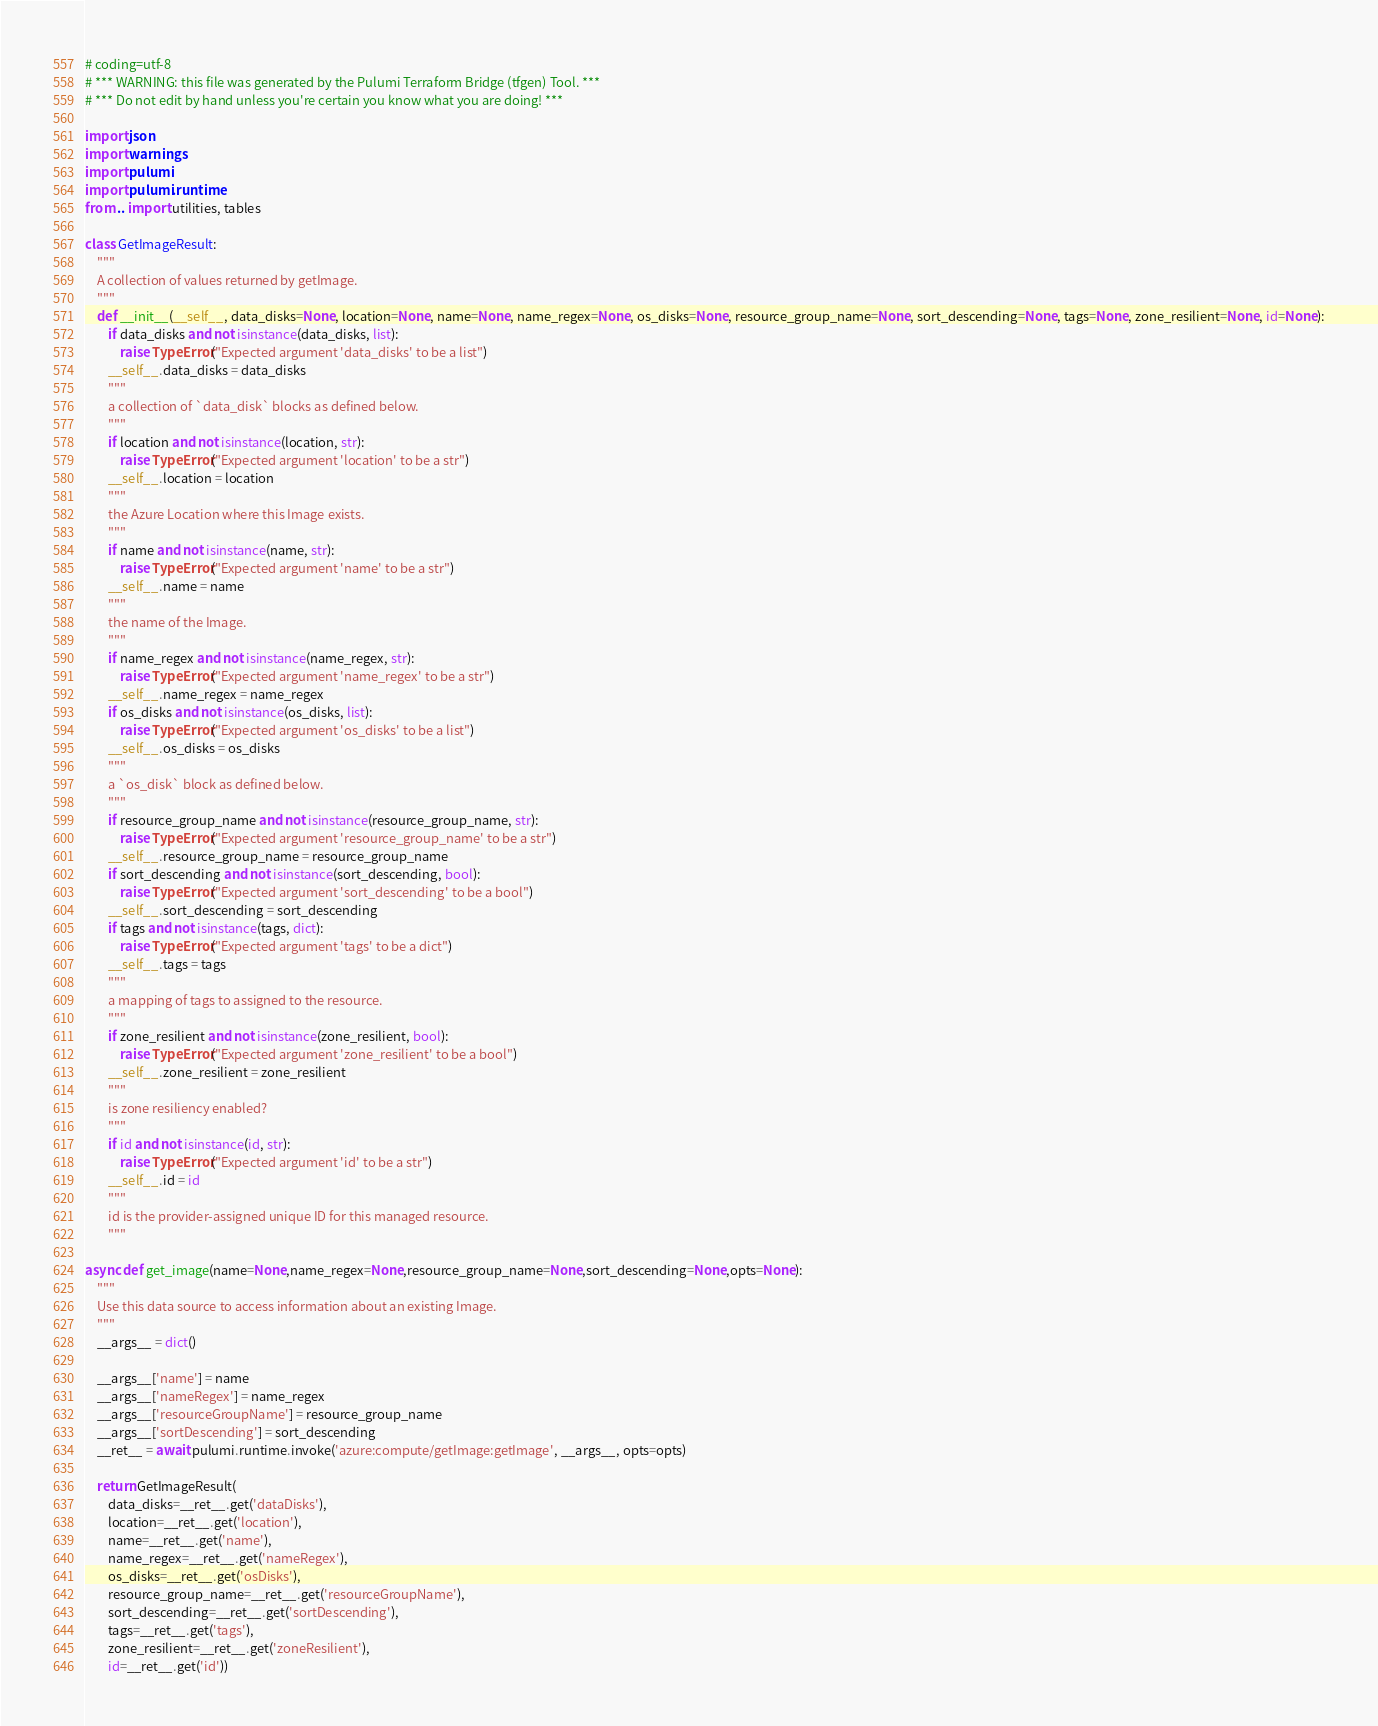<code> <loc_0><loc_0><loc_500><loc_500><_Python_># coding=utf-8
# *** WARNING: this file was generated by the Pulumi Terraform Bridge (tfgen) Tool. ***
# *** Do not edit by hand unless you're certain you know what you are doing! ***

import json
import warnings
import pulumi
import pulumi.runtime
from .. import utilities, tables

class GetImageResult:
    """
    A collection of values returned by getImage.
    """
    def __init__(__self__, data_disks=None, location=None, name=None, name_regex=None, os_disks=None, resource_group_name=None, sort_descending=None, tags=None, zone_resilient=None, id=None):
        if data_disks and not isinstance(data_disks, list):
            raise TypeError("Expected argument 'data_disks' to be a list")
        __self__.data_disks = data_disks
        """
        a collection of `data_disk` blocks as defined below.
        """
        if location and not isinstance(location, str):
            raise TypeError("Expected argument 'location' to be a str")
        __self__.location = location
        """
        the Azure Location where this Image exists.
        """
        if name and not isinstance(name, str):
            raise TypeError("Expected argument 'name' to be a str")
        __self__.name = name
        """
        the name of the Image.
        """
        if name_regex and not isinstance(name_regex, str):
            raise TypeError("Expected argument 'name_regex' to be a str")
        __self__.name_regex = name_regex
        if os_disks and not isinstance(os_disks, list):
            raise TypeError("Expected argument 'os_disks' to be a list")
        __self__.os_disks = os_disks
        """
        a `os_disk` block as defined below.
        """
        if resource_group_name and not isinstance(resource_group_name, str):
            raise TypeError("Expected argument 'resource_group_name' to be a str")
        __self__.resource_group_name = resource_group_name
        if sort_descending and not isinstance(sort_descending, bool):
            raise TypeError("Expected argument 'sort_descending' to be a bool")
        __self__.sort_descending = sort_descending
        if tags and not isinstance(tags, dict):
            raise TypeError("Expected argument 'tags' to be a dict")
        __self__.tags = tags
        """
        a mapping of tags to assigned to the resource.
        """
        if zone_resilient and not isinstance(zone_resilient, bool):
            raise TypeError("Expected argument 'zone_resilient' to be a bool")
        __self__.zone_resilient = zone_resilient
        """
        is zone resiliency enabled?
        """
        if id and not isinstance(id, str):
            raise TypeError("Expected argument 'id' to be a str")
        __self__.id = id
        """
        id is the provider-assigned unique ID for this managed resource.
        """

async def get_image(name=None,name_regex=None,resource_group_name=None,sort_descending=None,opts=None):
    """
    Use this data source to access information about an existing Image.
    """
    __args__ = dict()

    __args__['name'] = name
    __args__['nameRegex'] = name_regex
    __args__['resourceGroupName'] = resource_group_name
    __args__['sortDescending'] = sort_descending
    __ret__ = await pulumi.runtime.invoke('azure:compute/getImage:getImage', __args__, opts=opts)

    return GetImageResult(
        data_disks=__ret__.get('dataDisks'),
        location=__ret__.get('location'),
        name=__ret__.get('name'),
        name_regex=__ret__.get('nameRegex'),
        os_disks=__ret__.get('osDisks'),
        resource_group_name=__ret__.get('resourceGroupName'),
        sort_descending=__ret__.get('sortDescending'),
        tags=__ret__.get('tags'),
        zone_resilient=__ret__.get('zoneResilient'),
        id=__ret__.get('id'))
</code> 